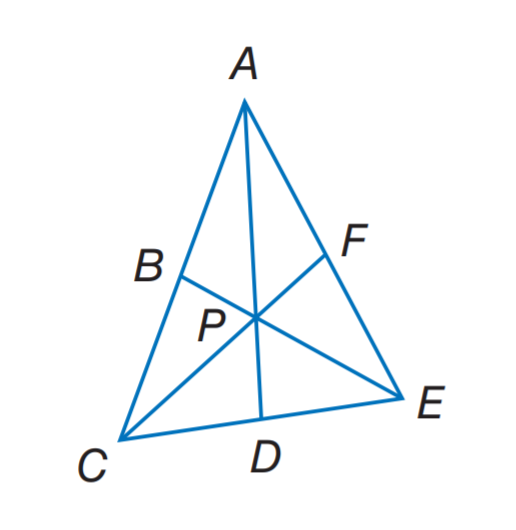Question: In \triangle A C E, P is the centroid. P F = 6 and A D = 15. Find P C.
Choices:
A. 6
B. 10
C. 12
D. 15
Answer with the letter. Answer: C Question: In \triangle A C E, P is the centroid. P F = 6 and A D = 15. Find A P.
Choices:
A. 6
B. 10
C. 12
D. 15
Answer with the letter. Answer: B 